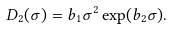Convert formula to latex. <formula><loc_0><loc_0><loc_500><loc_500>D _ { 2 } ( \sigma ) = b _ { 1 } \sigma ^ { 2 } \exp ( b _ { 2 } \sigma ) .</formula> 